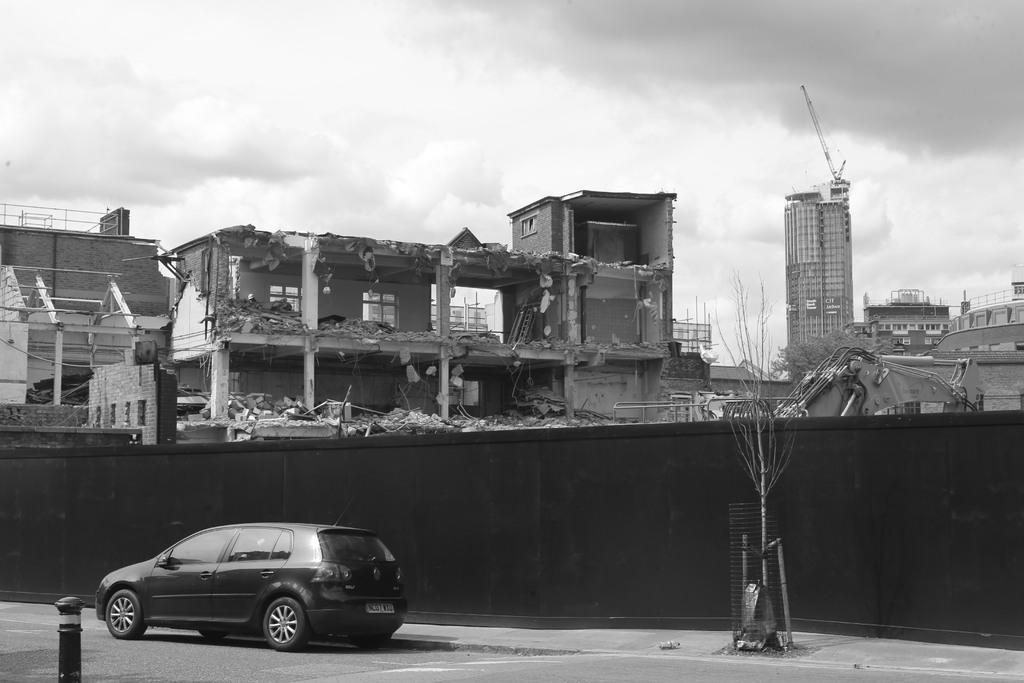What type of structures can be seen in the image? There are buildings in the image. What machinery is present in the image? There are cranes in the image. Can you describe the condition of one of the buildings in the image? There is a collapsed building in the image. What type of vegetation is visible in the image? There are trees in the image. How would you describe the weather in the image? The sky is cloudy in the image. What type of vehicle is present in the image? There is a black car in the image. How much profit can be made from the snow in the image? There is no snow present in the image, so it is not possible to determine any potential profit from it. 